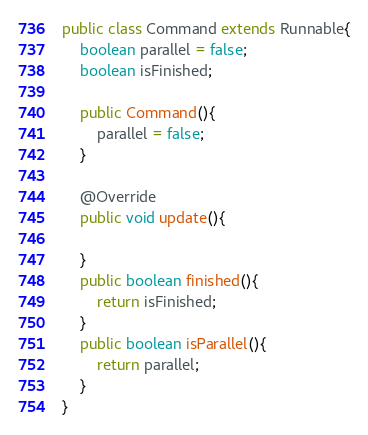Convert code to text. <code><loc_0><loc_0><loc_500><loc_500><_Java_>public class Command extends Runnable{
	boolean parallel = false;
	boolean isFinished;
	
	public Command(){
		parallel = false;
	}
	
	@Override
	public void update(){
	
	}
	public boolean finished(){
		return isFinished;
	}
	public boolean isParallel(){
		return parallel;
	}
}
</code> 